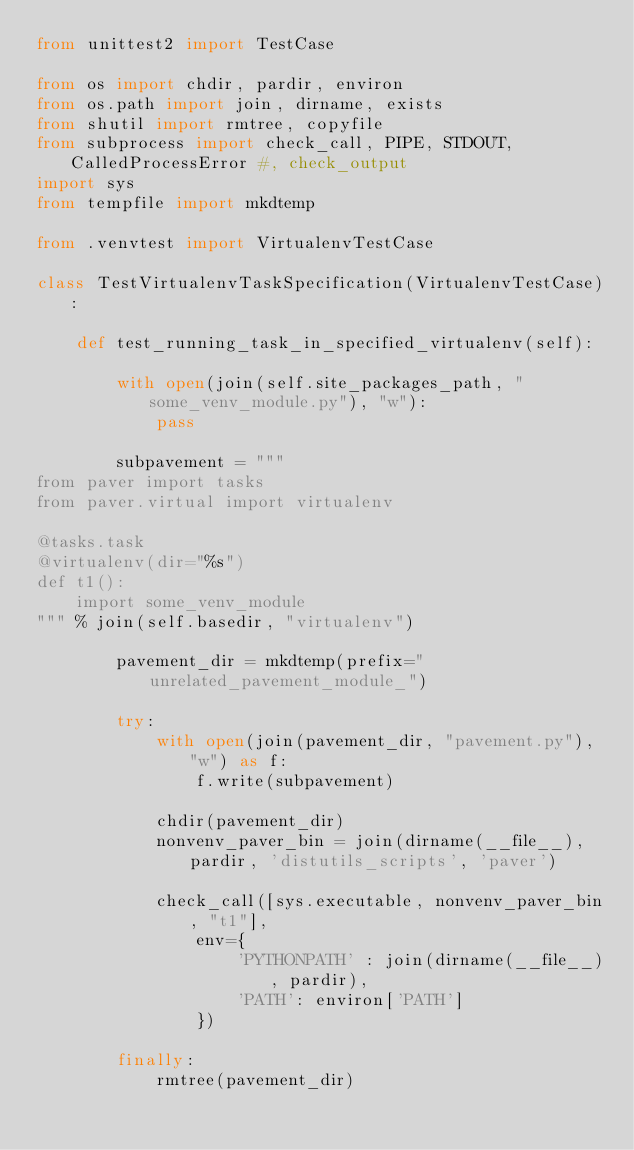Convert code to text. <code><loc_0><loc_0><loc_500><loc_500><_Python_>from unittest2 import TestCase

from os import chdir, pardir, environ
from os.path import join, dirname, exists
from shutil import rmtree, copyfile
from subprocess import check_call, PIPE, STDOUT, CalledProcessError #, check_output
import sys
from tempfile import mkdtemp

from .venvtest import VirtualenvTestCase

class TestVirtualenvTaskSpecification(VirtualenvTestCase):

    def test_running_task_in_specified_virtualenv(self):

        with open(join(self.site_packages_path, "some_venv_module.py"), "w"):
            pass

        subpavement = """
from paver import tasks
from paver.virtual import virtualenv

@tasks.task
@virtualenv(dir="%s")
def t1():
    import some_venv_module
""" % join(self.basedir, "virtualenv")

        pavement_dir = mkdtemp(prefix="unrelated_pavement_module_")

        try:
            with open(join(pavement_dir, "pavement.py"), "w") as f:
                f.write(subpavement)

            chdir(pavement_dir)
            nonvenv_paver_bin = join(dirname(__file__), pardir, 'distutils_scripts', 'paver')

            check_call([sys.executable, nonvenv_paver_bin, "t1"],
                env={
                    'PYTHONPATH' : join(dirname(__file__), pardir),
                    'PATH': environ['PATH']
                })

        finally:
            rmtree(pavement_dir)
</code> 